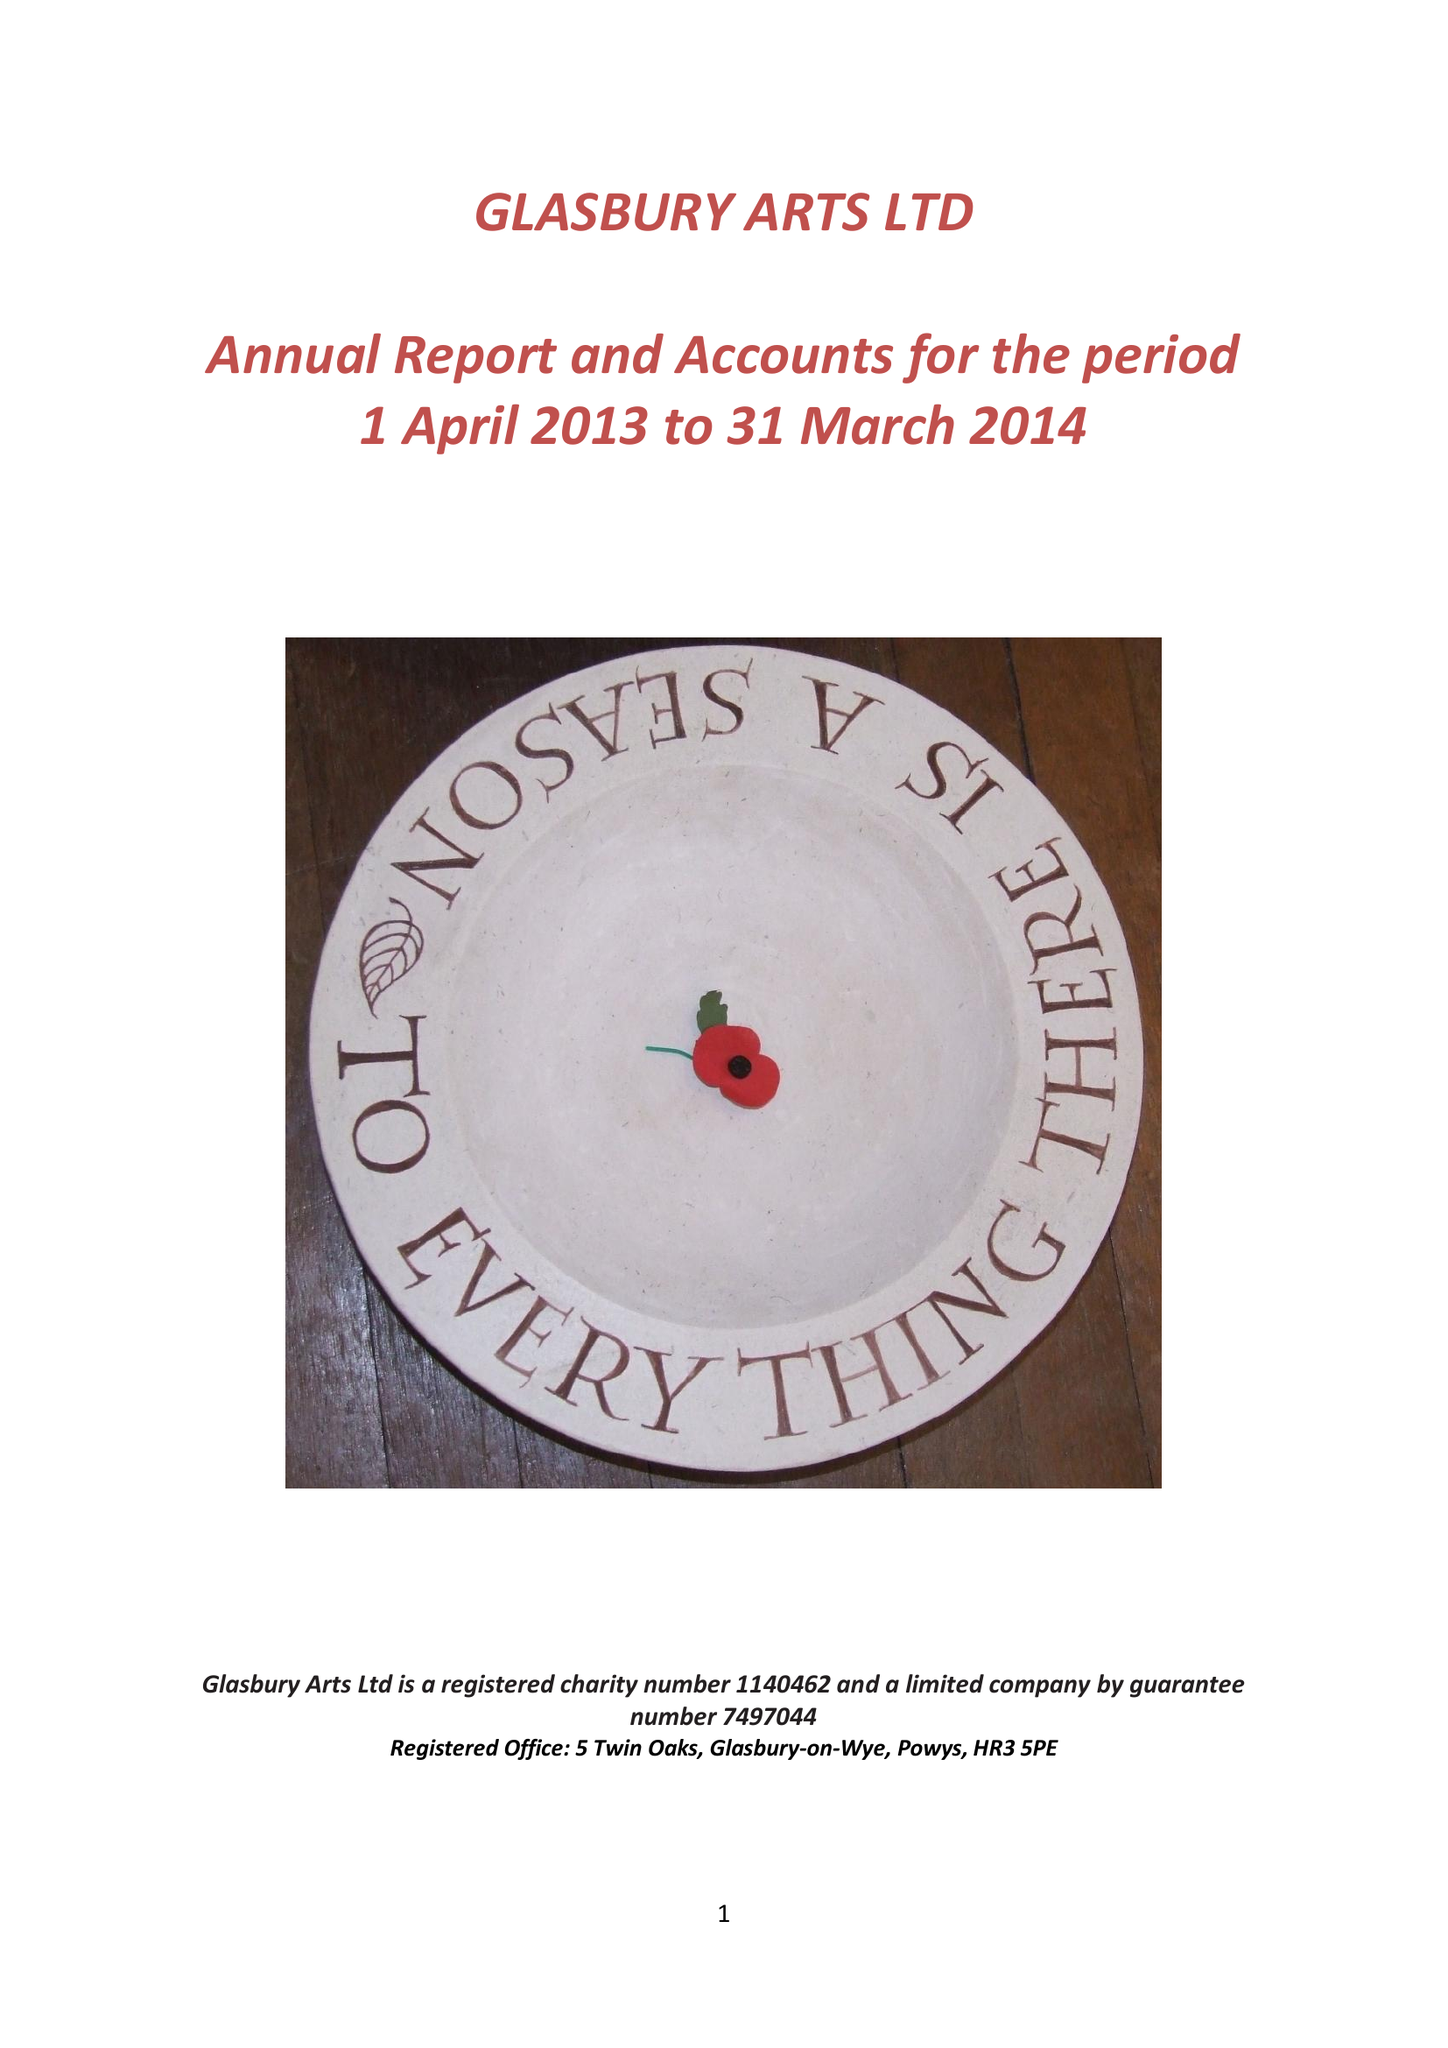What is the value for the address__postcode?
Answer the question using a single word or phrase. HR3 5PE 